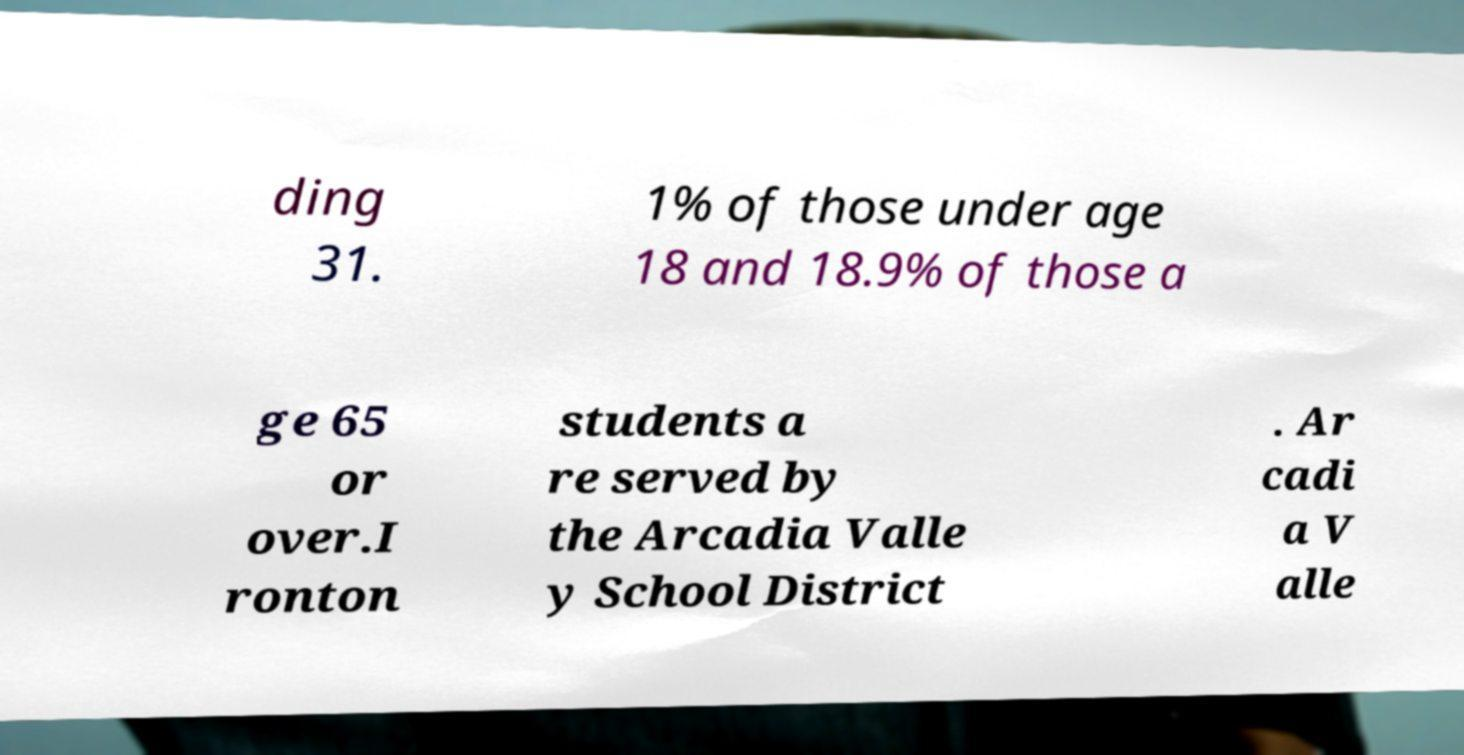I need the written content from this picture converted into text. Can you do that? ding 31. 1% of those under age 18 and 18.9% of those a ge 65 or over.I ronton students a re served by the Arcadia Valle y School District . Ar cadi a V alle 